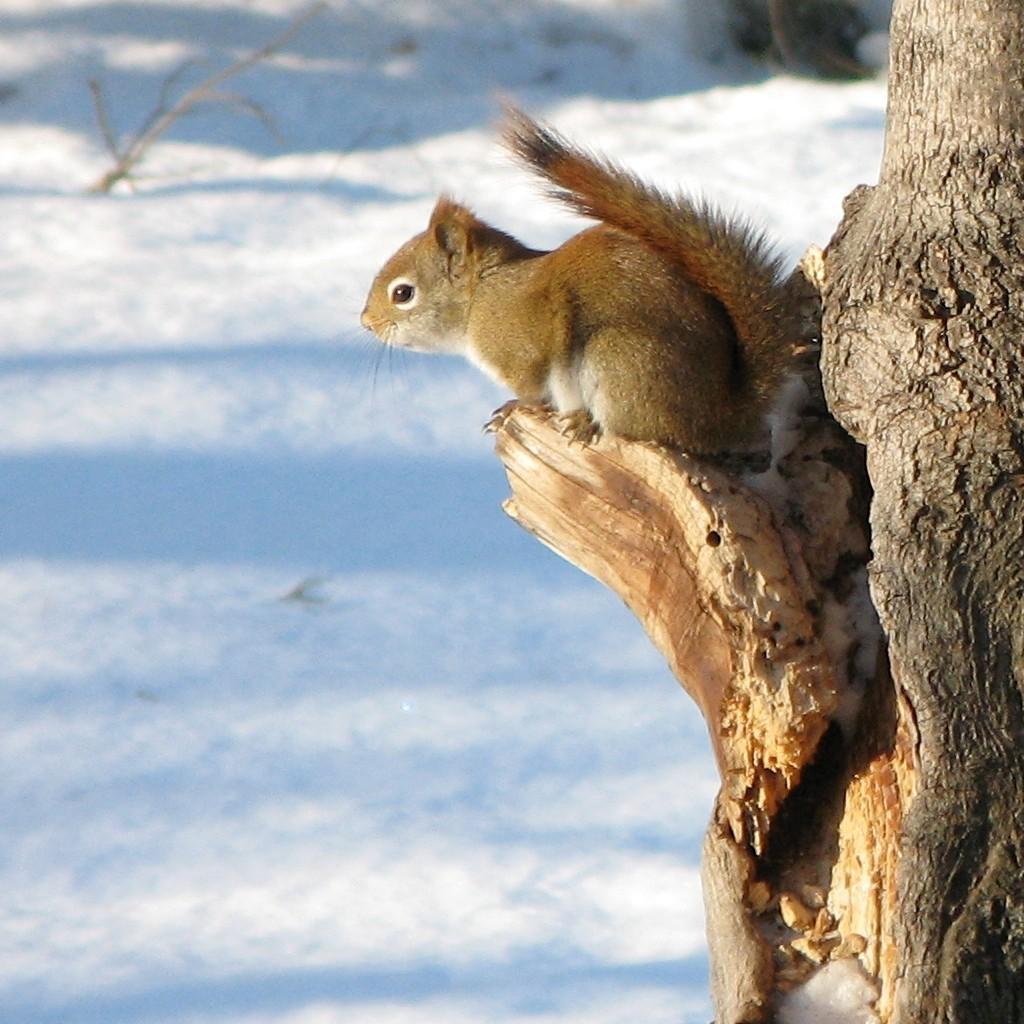In one or two sentences, can you explain what this image depicts? In this picture I can observe a squirrel on the tree. The squirrel is in brown color. In the background I can observe some snow on the land. 